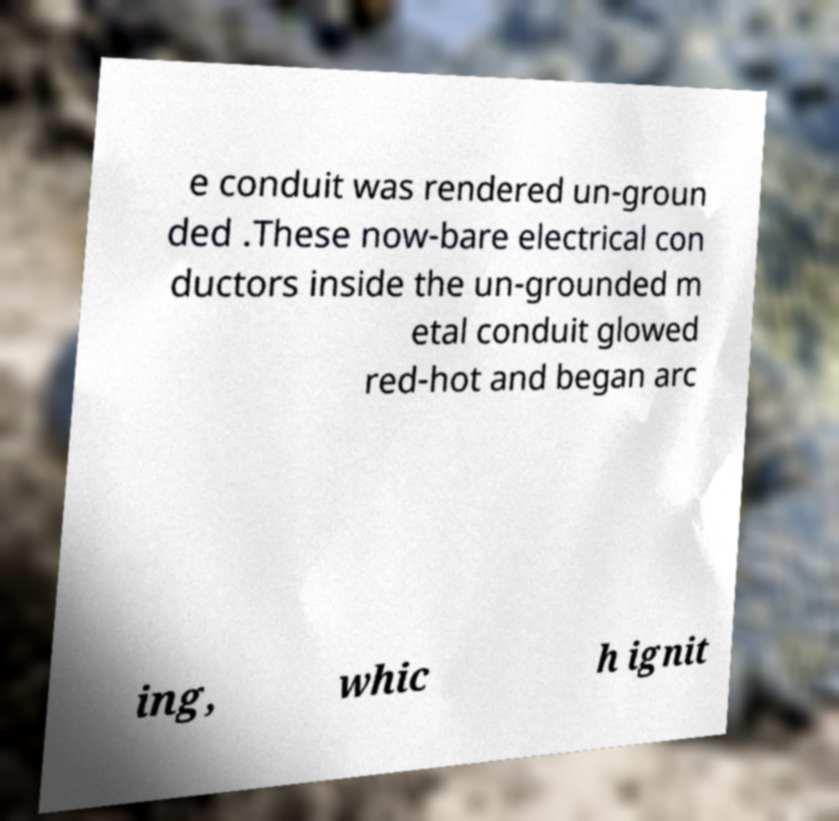Could you assist in decoding the text presented in this image and type it out clearly? e conduit was rendered un-groun ded .These now-bare electrical con ductors inside the un-grounded m etal conduit glowed red-hot and began arc ing, whic h ignit 